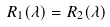<formula> <loc_0><loc_0><loc_500><loc_500>R _ { 1 } ( \lambda ) = R _ { 2 } ( \lambda )</formula> 